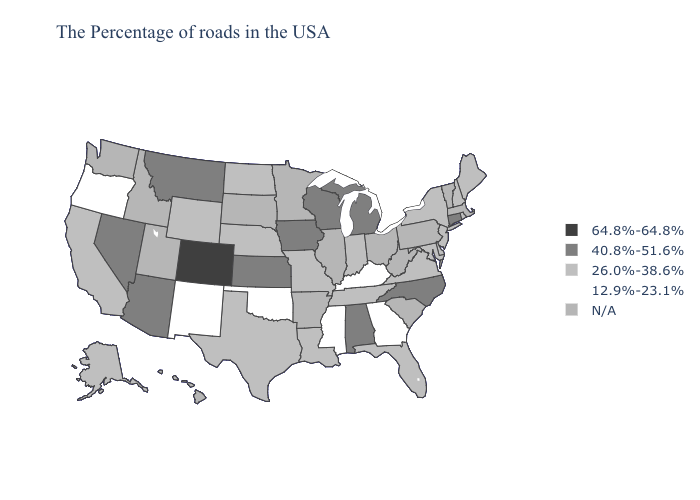What is the value of Alaska?
Give a very brief answer. 26.0%-38.6%. Does Oregon have the highest value in the West?
Quick response, please. No. What is the value of Oregon?
Answer briefly. 12.9%-23.1%. Among the states that border Kansas , which have the lowest value?
Give a very brief answer. Oklahoma. Does the map have missing data?
Quick response, please. Yes. What is the highest value in the USA?
Write a very short answer. 64.8%-64.8%. Does Colorado have the lowest value in the USA?
Short answer required. No. Does Nebraska have the highest value in the MidWest?
Write a very short answer. No. Among the states that border Louisiana , which have the lowest value?
Concise answer only. Mississippi. What is the highest value in the MidWest ?
Quick response, please. 40.8%-51.6%. Name the states that have a value in the range N/A?
Write a very short answer. Massachusetts, Vermont, Pennsylvania, South Carolina, West Virginia, Ohio, Illinois, Arkansas, Minnesota, South Dakota, Utah, Idaho, Washington, Hawaii. Name the states that have a value in the range 12.9%-23.1%?
Short answer required. Georgia, Kentucky, Mississippi, Oklahoma, New Mexico, Oregon. Among the states that border North Carolina , which have the highest value?
Be succinct. Virginia, Tennessee. 